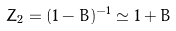<formula> <loc_0><loc_0><loc_500><loc_500>Z _ { 2 } = ( 1 - B ) ^ { - 1 } \simeq 1 + B</formula> 